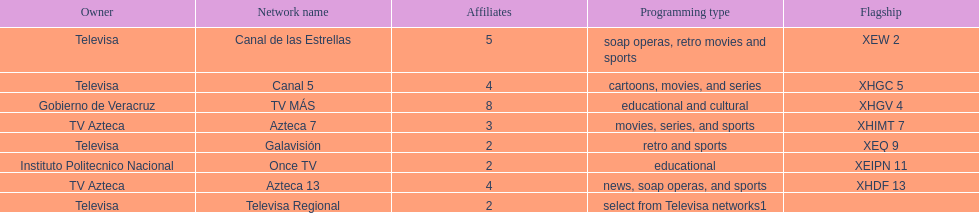How many networks have more affiliates than canal de las estrellas? 1. 